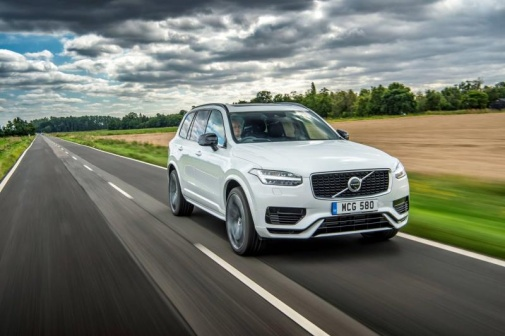Create a short story involving the vehicle in the image. Under the overcast sky, the Volvo XC90 roared to life on the quiet country road. Blake, a seasoned travel photographer, was behind the wheel, eager to capture the beauty after the rain. As the journey unfolded, he encountered a mysterious stranger on foot, drenched yet determined, seeking a ride to the nearby town. This chance meeting led to an unexpected adventure through the countryside, where they uncovered hidden landmarks and secret stories. By the end of the day, Blake's camera was full of extraordinary shots, and he had made a new friend, turning a simple drive into an unforgettable tale of discovery and connection. 